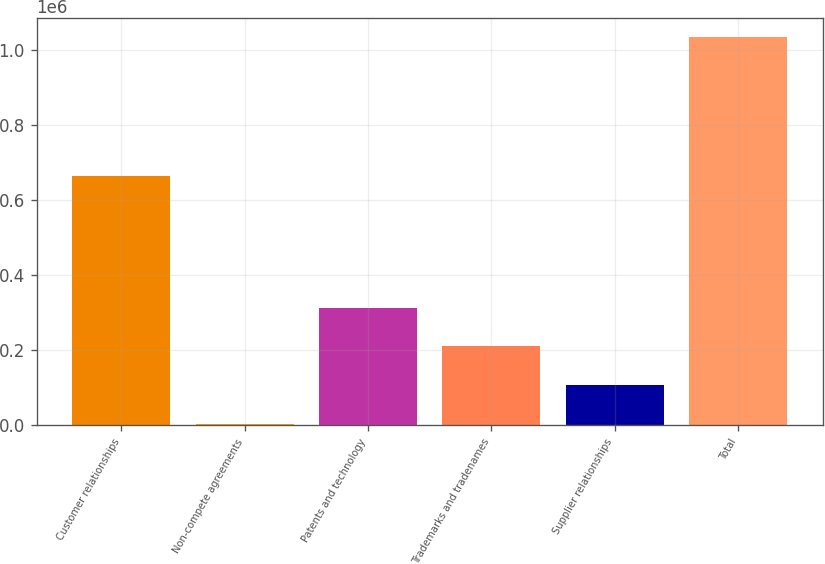<chart> <loc_0><loc_0><loc_500><loc_500><bar_chart><fcel>Customer relationships<fcel>Non-compete agreements<fcel>Patents and technology<fcel>Trademarks and tradenames<fcel>Supplier relationships<fcel>Total<nl><fcel>663532<fcel>4738<fcel>313189<fcel>210372<fcel>107555<fcel>1.03291e+06<nl></chart> 